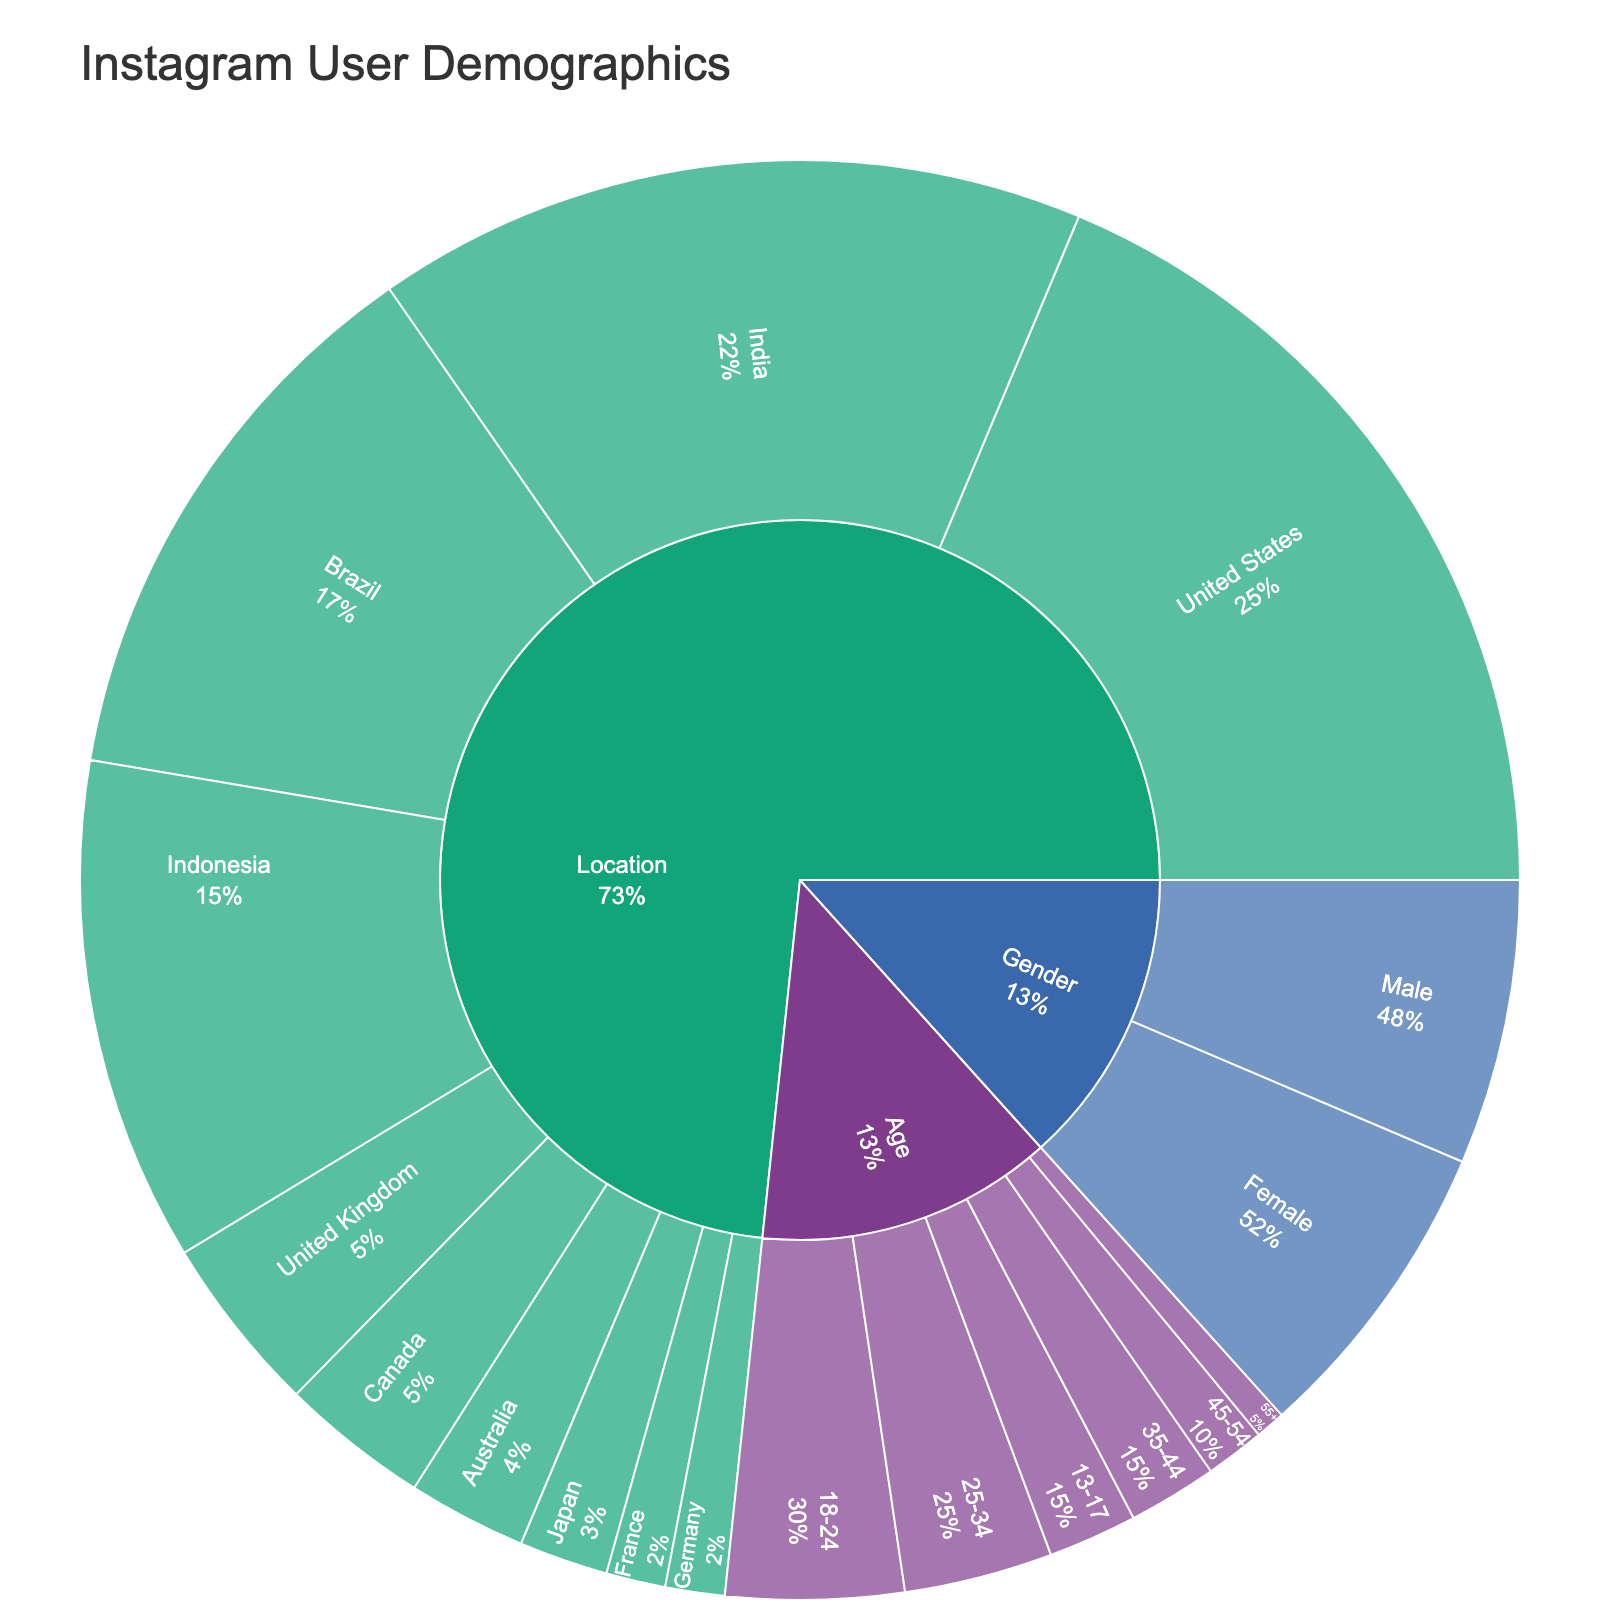How many age groups are represented in the plot? The sunburst plot displays different age groups as subdivisions under the "Age" category. Count each unique age group.
Answer: 6 What percentage of Instagram users are aged 18-24? Locate the section for the 18-24 age group under "Age" and find the percentage indicated relative to the total "Age" category.
Answer: 30% Which gender has a higher percentage of users? Compare the two sections under the "Gender" category to see which has a larger percentage.
Answer: Female What is the total number of users from the United States and India combined? Add the values for the United States (140) and India (120) under the "Location" category. 140 + 120 = 260.
Answer: 260 Which location has the smallest number of users, and how many are they? Locate the section with the smallest value under the "Location" category and read the value.
Answer: Germany and France, 10 each Compare the percentages of users in the 25-34 age group to the 13-17 age group within the "Age" category. Which is larger and by how much? Locate the sections for 25-34 (25%) and 13-17 (15%) and calculate the difference. 25% - 15% = 10%.
Answer: 25-34 is larger by 10% What fraction of Instagram users are from Brazil out of the total location count? Identify the value for Brazil (95) and calculate it as a fraction of the total of all location values. Total = 140 + 120 + 95 + 85 + 30 + 25 + 20 + 15 + 10 + 10 = 550; thus, 95/550.
Answer: 95/550 How do the user percentages in the 45-54 age group compare with those in the 35-44 age group? Compare the percentages given for the 45-54 age group (10%) and the 35-44 age group (15%) according to the total "Age" category.
Answer: The 35-44 age group is larger by 5% In terms of value, how many more users are there in Indonesia compared to Canada? Identify the values for Indonesia (85) and Canada (25) and subtract the smaller from the larger. 85 - 25 = 60.
Answer: 60 Which three locations outside the United States have the highest user counts, and in what order? Sort the values under the "Location" category (excluding the United States) and identify the top three. Values are India (120), Brazil (95), Indonesia (85). Order: 1) India, 2) Brazil, 3) Indonesia.
Answer: India, Brazil, Indonesia 